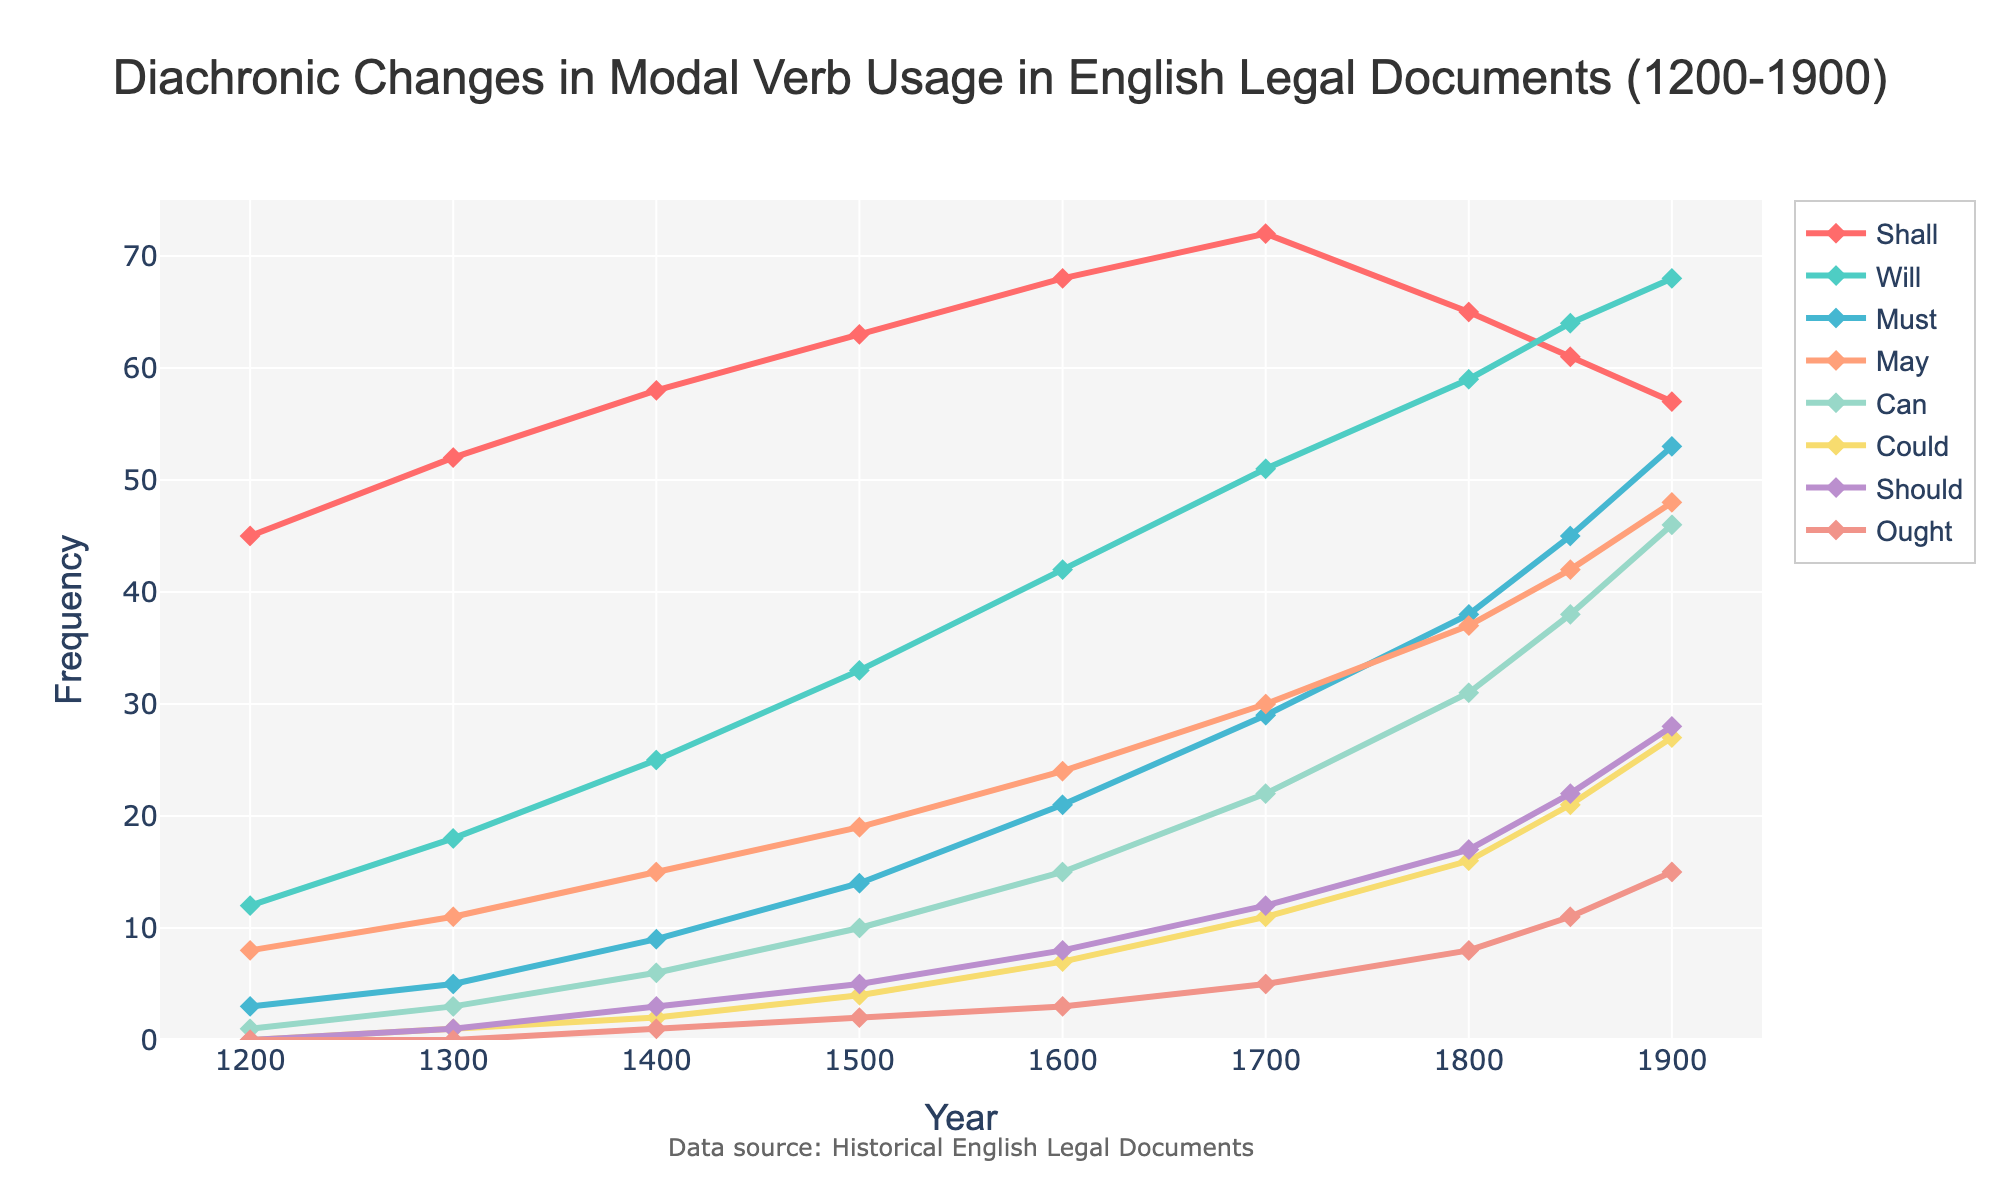Which modal verb shows steady growth in usage from 1200 to 1900? By observing the trend lines, "Will" shows steady growth without significant dips from 1200 to 1900.
Answer: Will Which modal verb experienced the largest increase in usage by 1900 compared to its initial value in 1200? For each modal verb, calculate the difference between its value in 1200 and 1900. "Must" increases from 3 to 53, which is the largest increase (53 - 3 = 50).
Answer: Must What is the sum of the frequencies of "May" and "Can" in the year 1800? Look at the values for "May" and "Can" in 1800: 37 (May) and 31 (Can). Adding these gives 37 + 31 = 68.
Answer: 68 Which two modal verbs' usage crossover occurs around the year 1700? "Will" and "Shall" show a crossover near 1700, where "Will" overtakes "Shall". The line for "Will" rises while "Shall" comes down.
Answer: Will, Shall What is the trend pattern seen for the modal verb "Shall" from 1200 to 1900? "Shall" steadily increases until 1700 and then declines from 1800 and onwards.
Answer: Increases until 1700, then declines Which modal verb had the smallest usage around 1300? By comparing the data points for the year 1300, "Could" has the smallest usage with a value of 1.
Answer: Could How much more frequent was "Will" compared to "Must" in the year 1500? The figure shows "Will" has a frequency of 33 and "Must" 14 in 1500. Therefore, 33 - 14 = 19.
Answer: 19 Which modal verb has shown a relatively stable low usage throughout the timeline? "Ought" appears to have consistently low usage across the years, maintaining minimal values from 1200 to 1900.
Answer: Ought What is the difference in frequency of "Should" between 1600 and 1900? "Should" has a frequency of 8 in 1600 and 28 in 1900. Thus, 28 - 8 = 20.
Answer: 20 How do the frequencies of "Shall" and "Will" compare in 1850? In 1850, "Shall" has a frequency of 61, and "Will" has 64. The usage of "Will" slightly exceeds that of "Shall".
Answer: "Will" slightly higher 